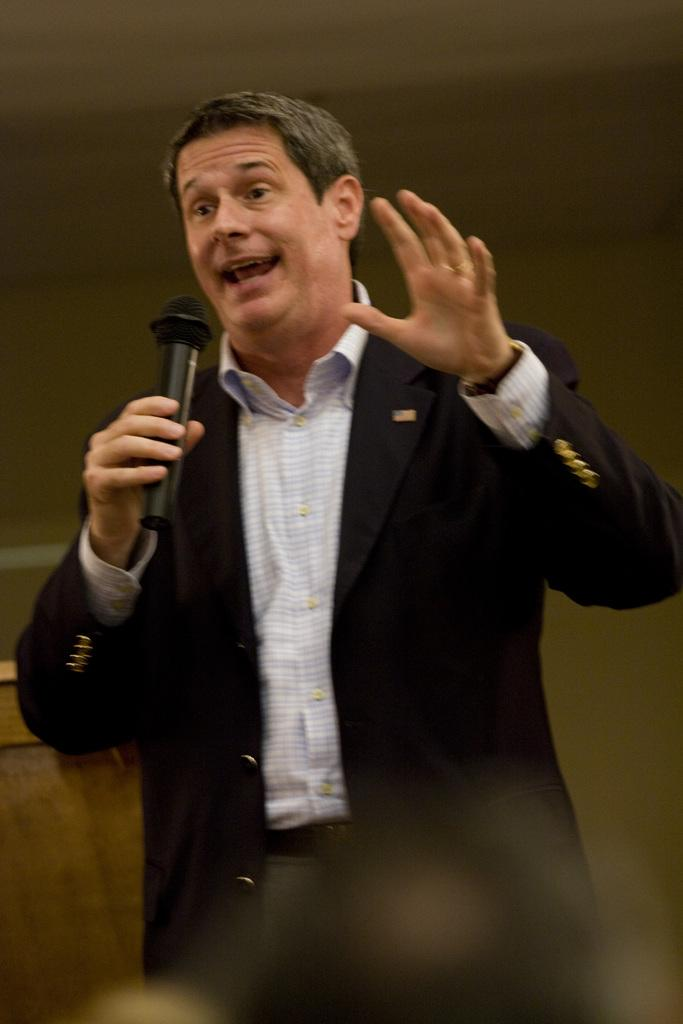What is the man in the image doing? The man is standing and speaking in the image. What is the man holding in his hand? The man is holding a microphone in his hand. What can be seen in the background of the image? There is a wall in the background of the image. What type of thing is the man pulling out of the drawer in the image? There is no drawer or thing being pulled out in the image; the man is holding a microphone and standing in front of a wall. 